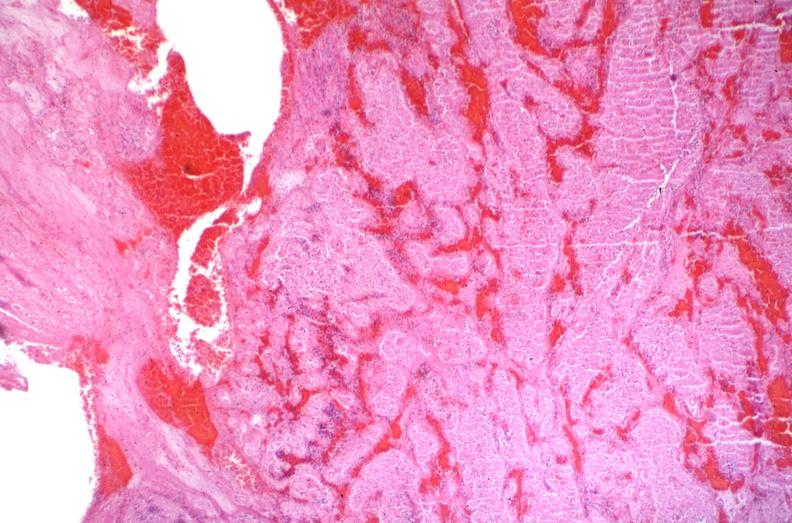what does this image show?
Answer the question using a single word or phrase. Sickle cell disease 